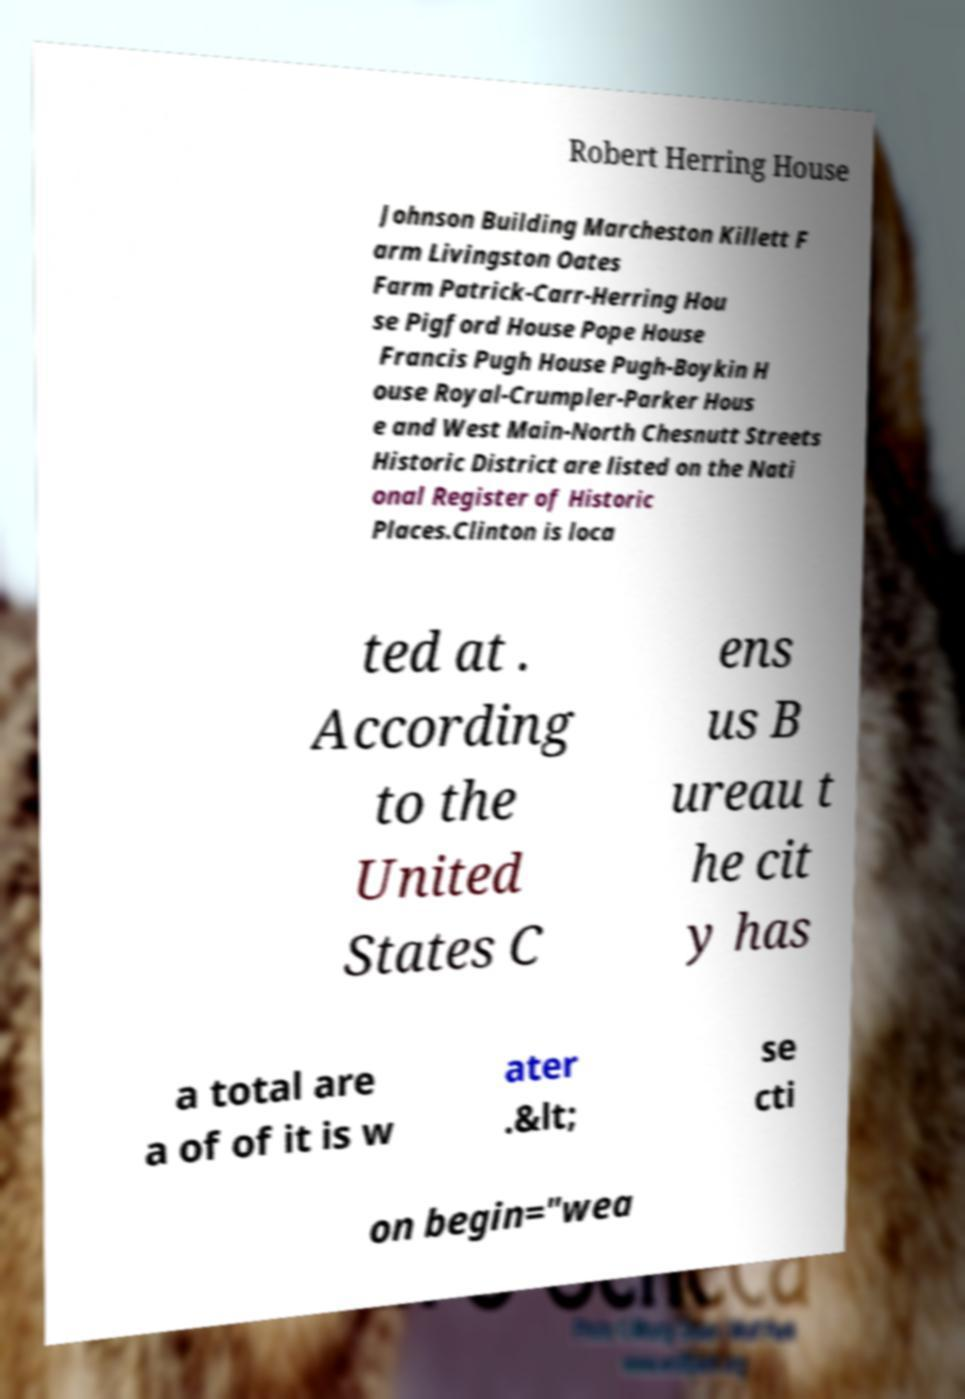I need the written content from this picture converted into text. Can you do that? Robert Herring House Johnson Building Marcheston Killett F arm Livingston Oates Farm Patrick-Carr-Herring Hou se Pigford House Pope House Francis Pugh House Pugh-Boykin H ouse Royal-Crumpler-Parker Hous e and West Main-North Chesnutt Streets Historic District are listed on the Nati onal Register of Historic Places.Clinton is loca ted at . According to the United States C ens us B ureau t he cit y has a total are a of of it is w ater .&lt; se cti on begin="wea 